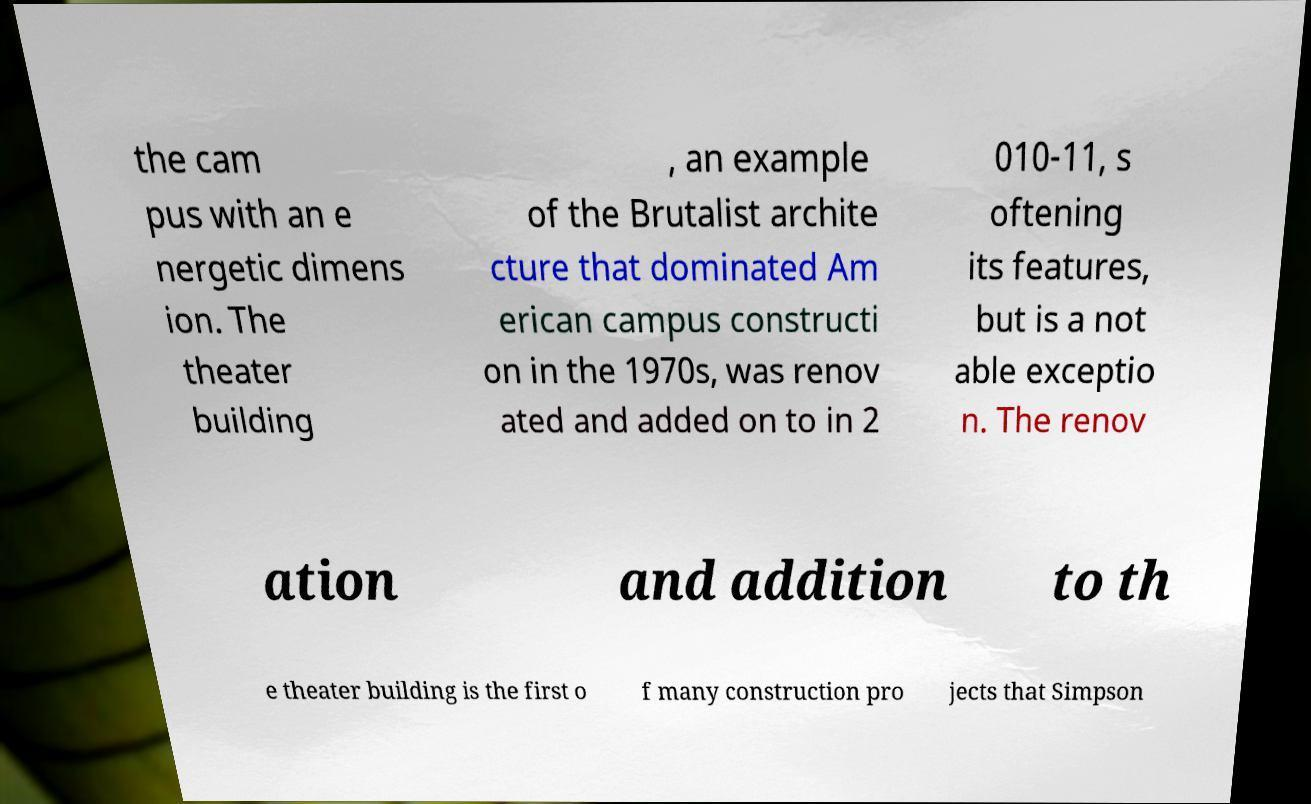Could you extract and type out the text from this image? the cam pus with an e nergetic dimens ion. The theater building , an example of the Brutalist archite cture that dominated Am erican campus constructi on in the 1970s, was renov ated and added on to in 2 010-11, s oftening its features, but is a not able exceptio n. The renov ation and addition to th e theater building is the first o f many construction pro jects that Simpson 